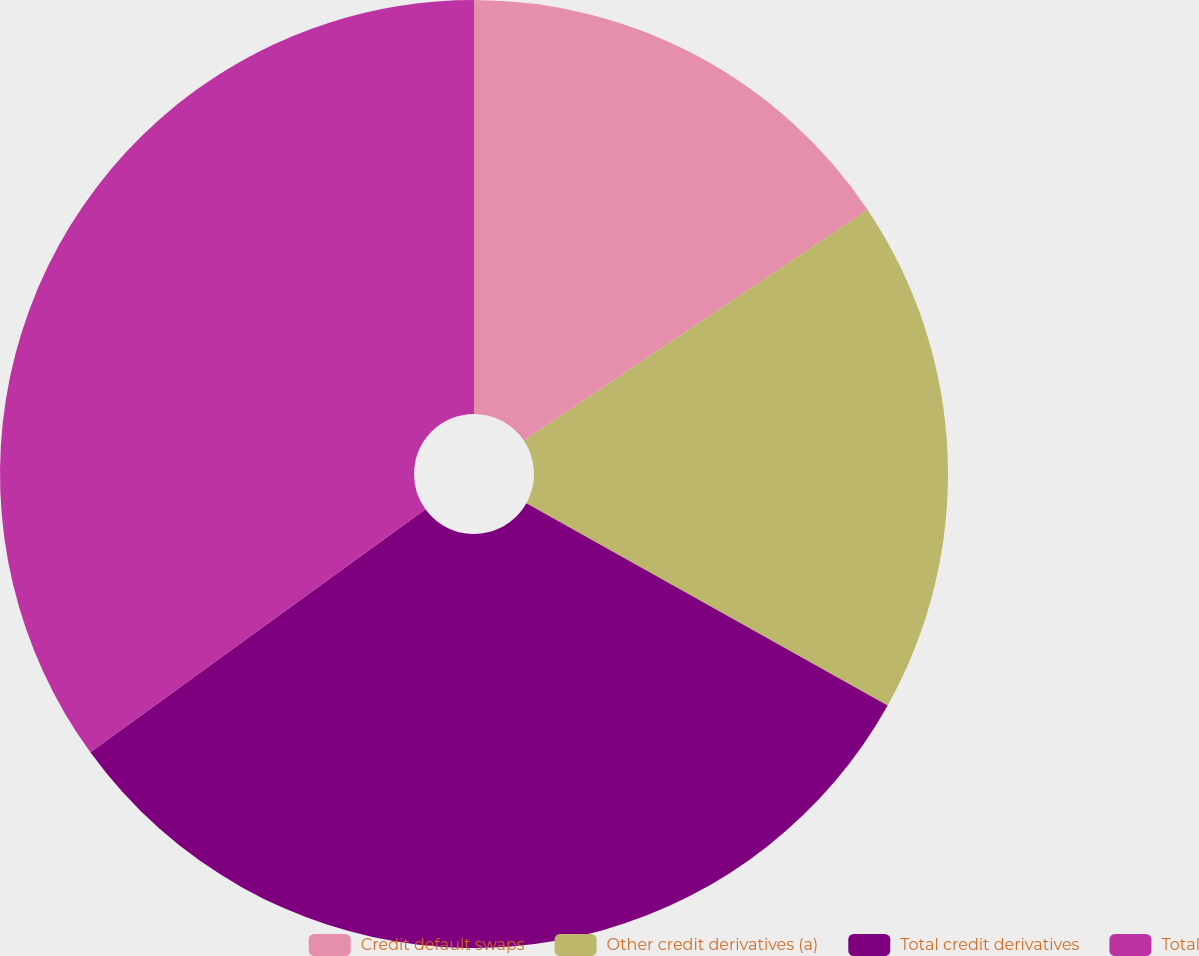Convert chart to OTSL. <chart><loc_0><loc_0><loc_500><loc_500><pie_chart><fcel>Credit default swaps<fcel>Other credit derivatives (a)<fcel>Total credit derivatives<fcel>Total<nl><fcel>15.59%<fcel>17.53%<fcel>31.89%<fcel>34.99%<nl></chart> 